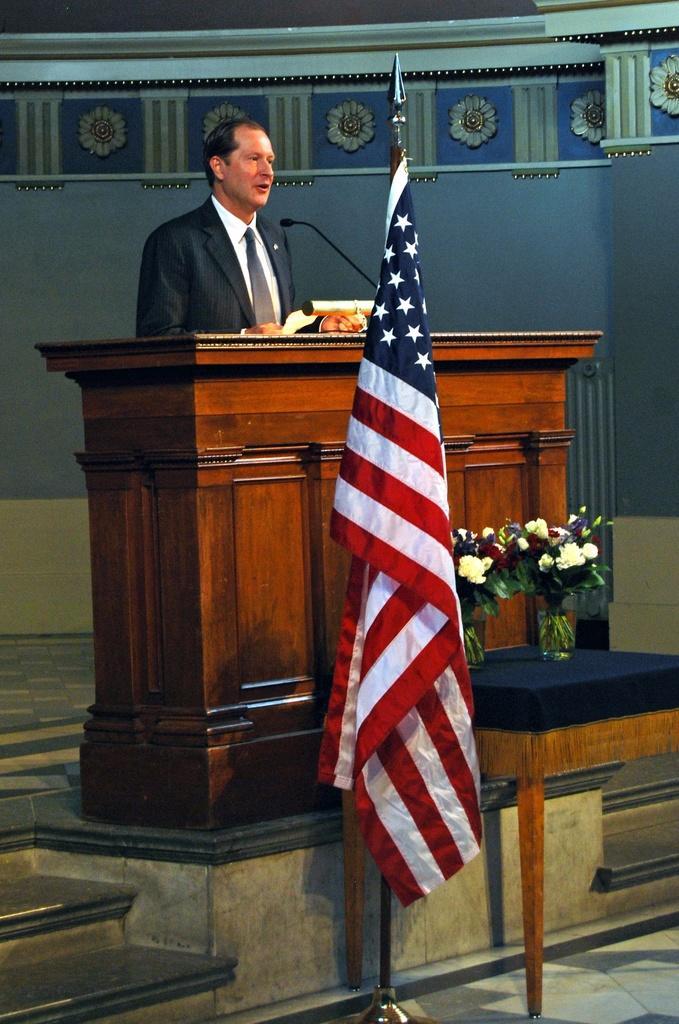Can you describe this image briefly? In this picture I can see there is a man standing and he is wearing a blazer, tie and a shirt and there is a wooden table in front of him and there is a microphone on the table and there is a flag here and there is another table with two flower pots and there are stairs on to left and in the backdrop there is a wall. 